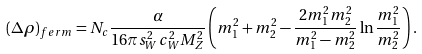<formula> <loc_0><loc_0><loc_500><loc_500>( \Delta \rho ) _ { f e r m } = N _ { c } \frac { \alpha } { 1 6 \pi s _ { W } ^ { 2 } c _ { W } ^ { 2 } M _ { Z } ^ { 2 } } \left ( m _ { 1 } ^ { 2 } + m _ { 2 } ^ { 2 } - \frac { 2 m _ { 1 } ^ { 2 } m _ { 2 } ^ { 2 } } { m _ { 1 } ^ { 2 } - m _ { 2 } ^ { 2 } } \ln \frac { m _ { 1 } ^ { 2 } } { m _ { 2 } ^ { 2 } } \right ) .</formula> 